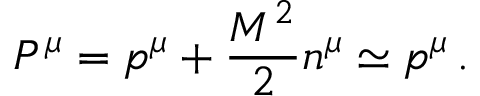Convert formula to latex. <formula><loc_0><loc_0><loc_500><loc_500>P ^ { \mu } = p ^ { \mu } + \frac { M ^ { 2 } } { 2 } n ^ { \mu } \simeq p ^ { \mu } \, .</formula> 